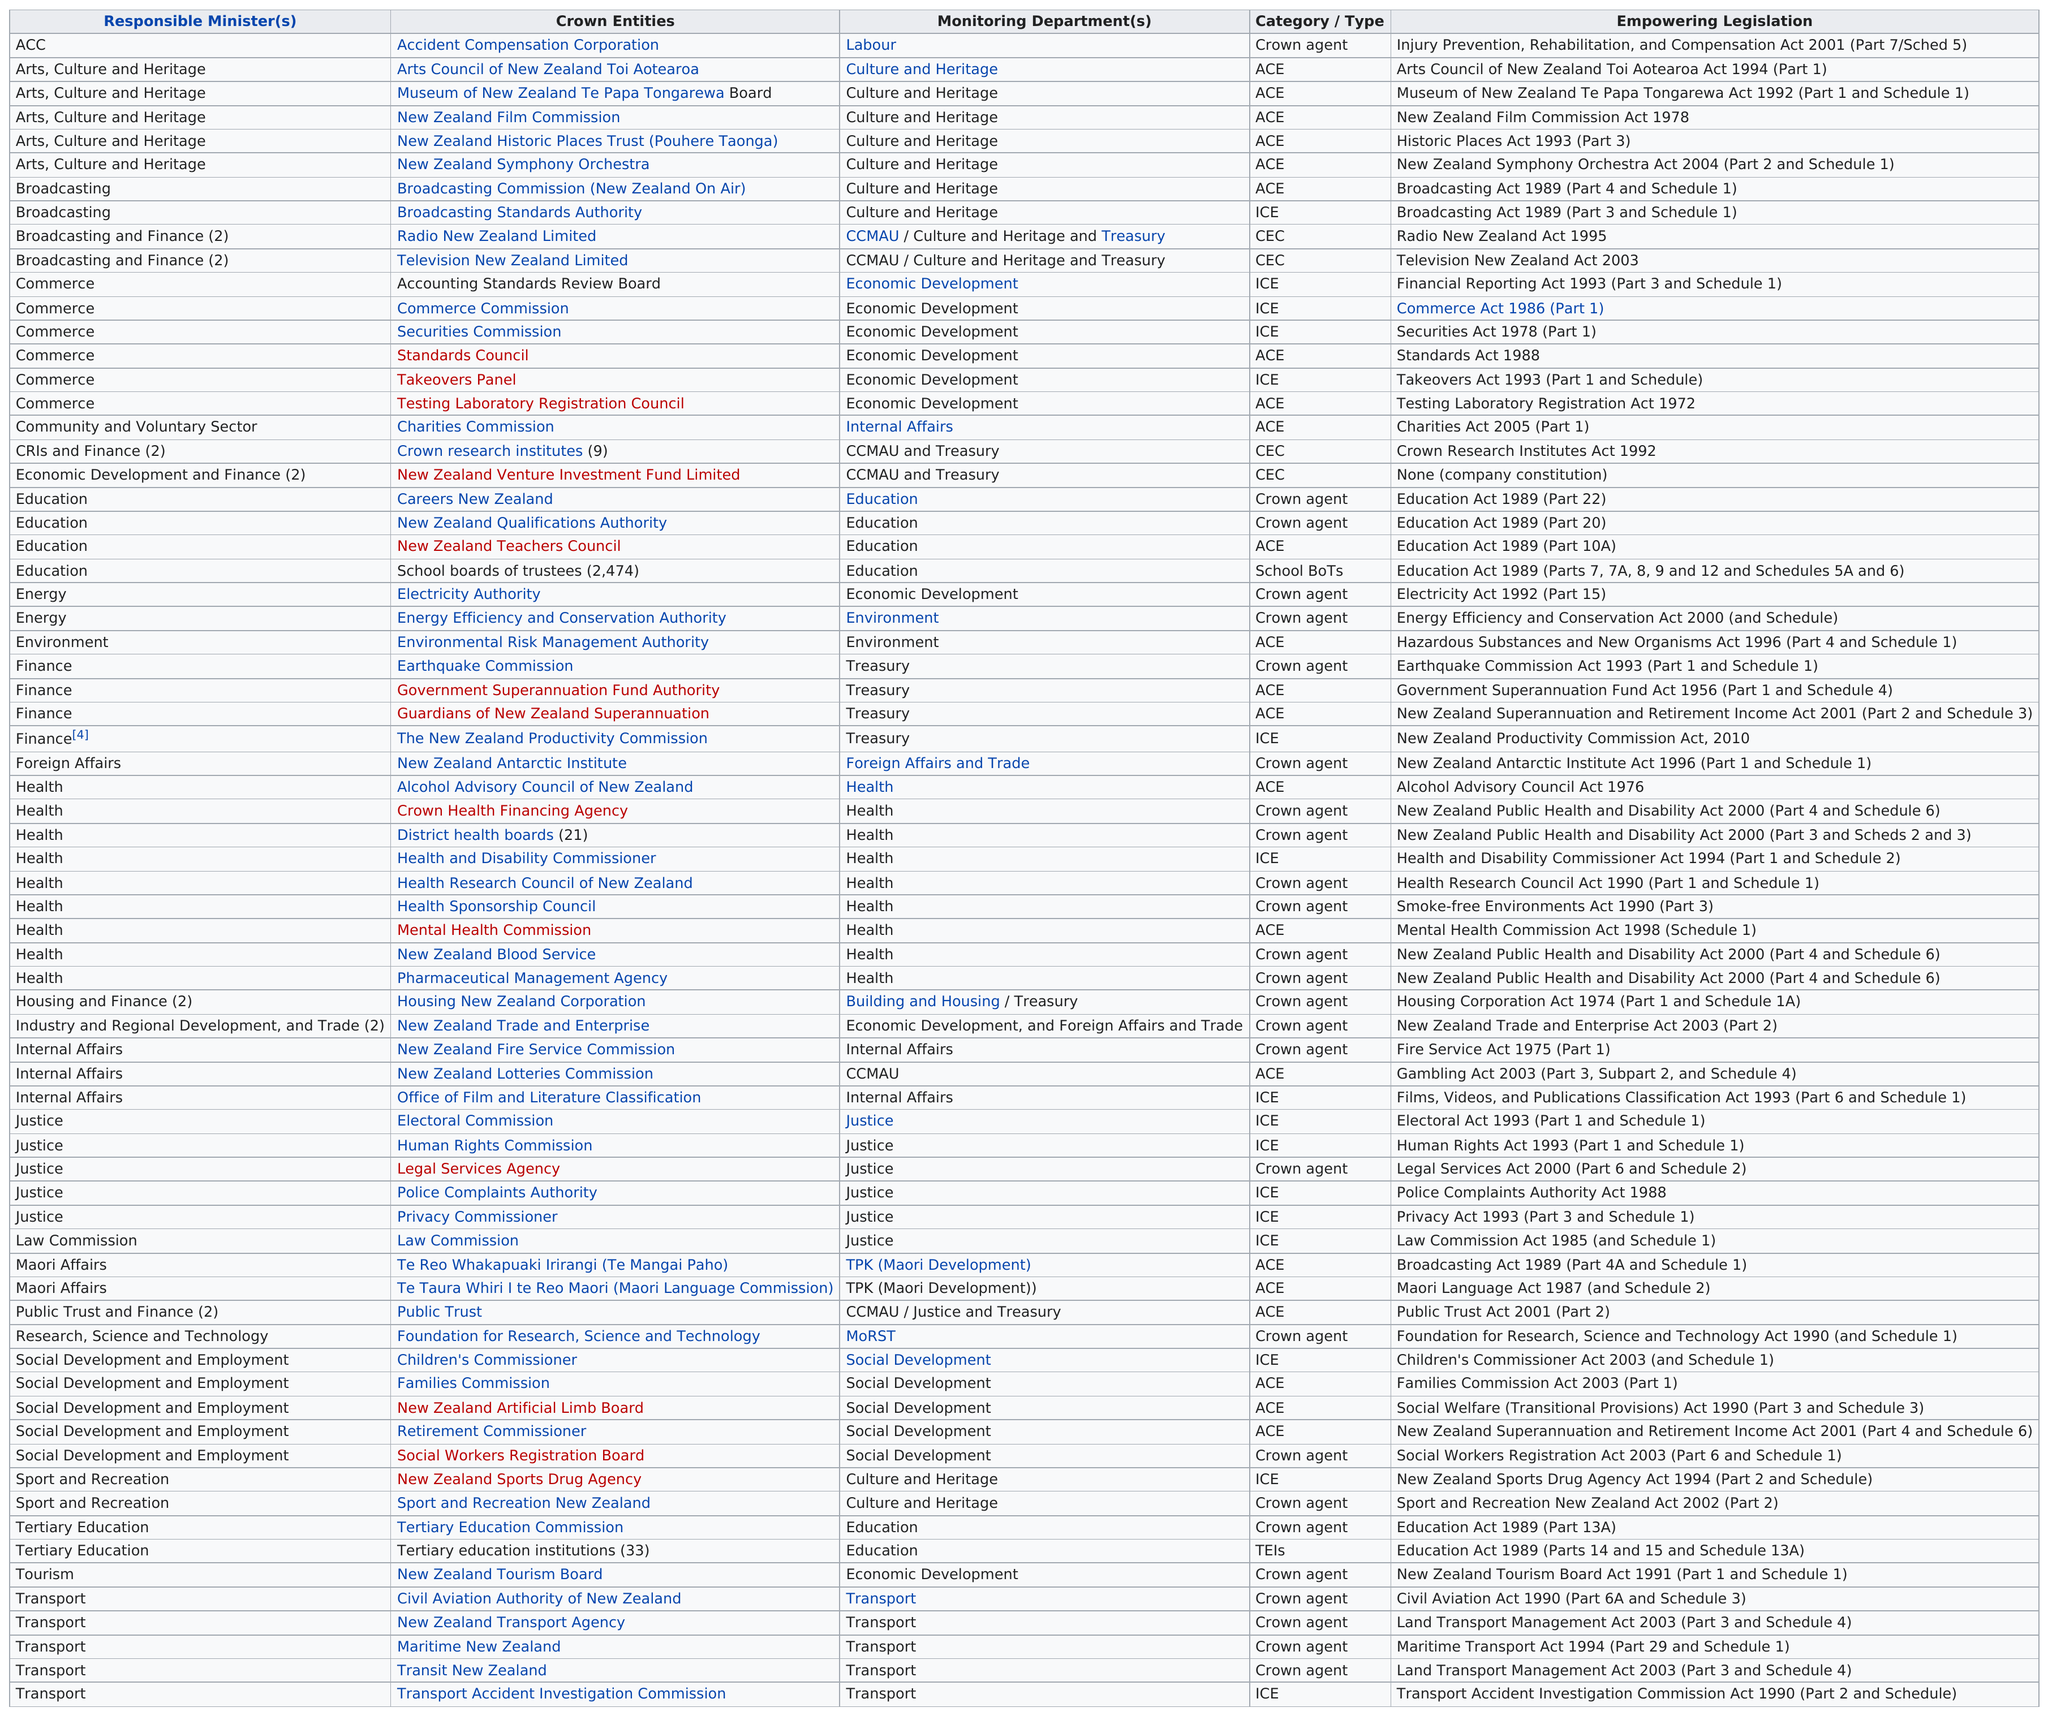Identify some key points in this picture. Approximately 22 companies fall under the ACE category. The category listed after 'Crown Agent' is 'Monitoring Department(s).'. The minister responsible for health has introduced the greatest number of empowering legislations. The empowering legislation for the New Zealand Film Commission was enacted 17 years after the empowering legislation for Radio New Zealand Limited. As of my knowledge cutoff, there are 4 entities that have finance as a responsible minister. 